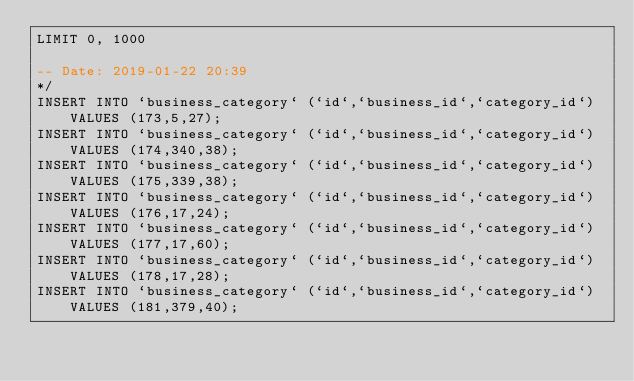Convert code to text. <code><loc_0><loc_0><loc_500><loc_500><_SQL_>LIMIT 0, 1000

-- Date: 2019-01-22 20:39
*/
INSERT INTO `business_category` (`id`,`business_id`,`category_id`) VALUES (173,5,27);
INSERT INTO `business_category` (`id`,`business_id`,`category_id`) VALUES (174,340,38);
INSERT INTO `business_category` (`id`,`business_id`,`category_id`) VALUES (175,339,38);
INSERT INTO `business_category` (`id`,`business_id`,`category_id`) VALUES (176,17,24);
INSERT INTO `business_category` (`id`,`business_id`,`category_id`) VALUES (177,17,60);
INSERT INTO `business_category` (`id`,`business_id`,`category_id`) VALUES (178,17,28);
INSERT INTO `business_category` (`id`,`business_id`,`category_id`) VALUES (181,379,40);
</code> 